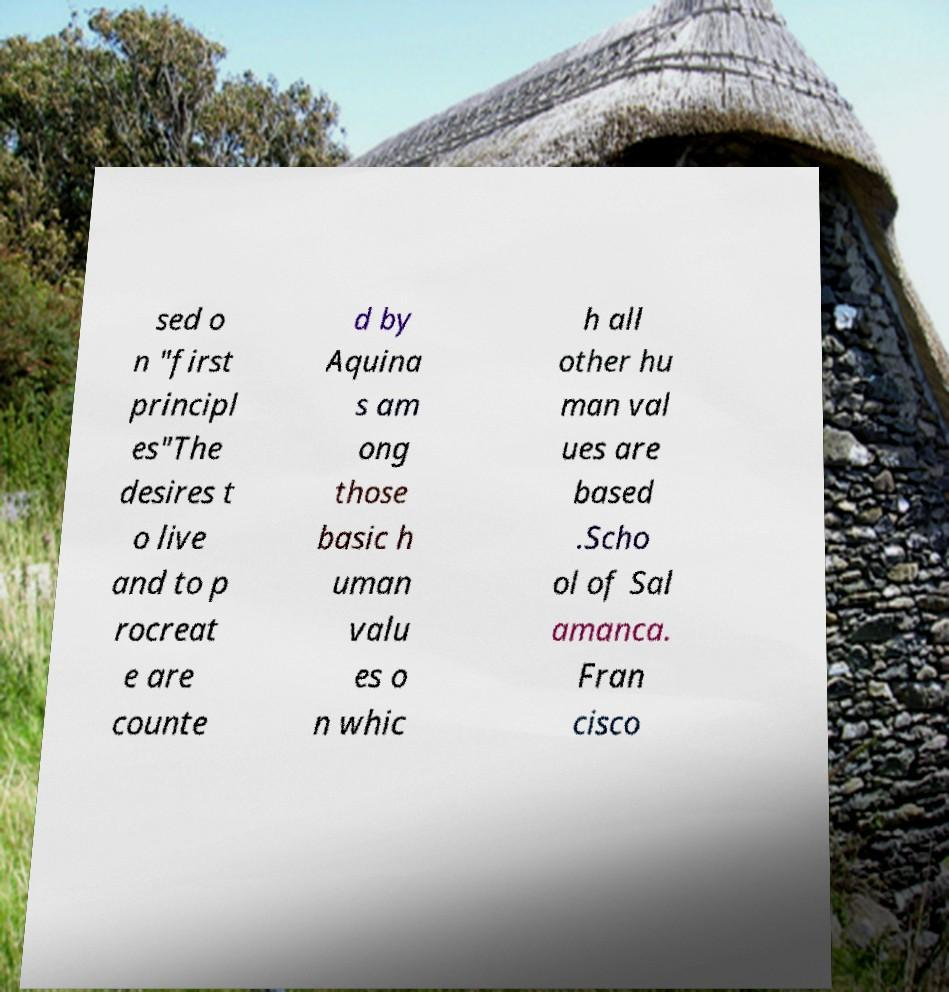Please read and relay the text visible in this image. What does it say? sed o n "first principl es"The desires t o live and to p rocreat e are counte d by Aquina s am ong those basic h uman valu es o n whic h all other hu man val ues are based .Scho ol of Sal amanca. Fran cisco 